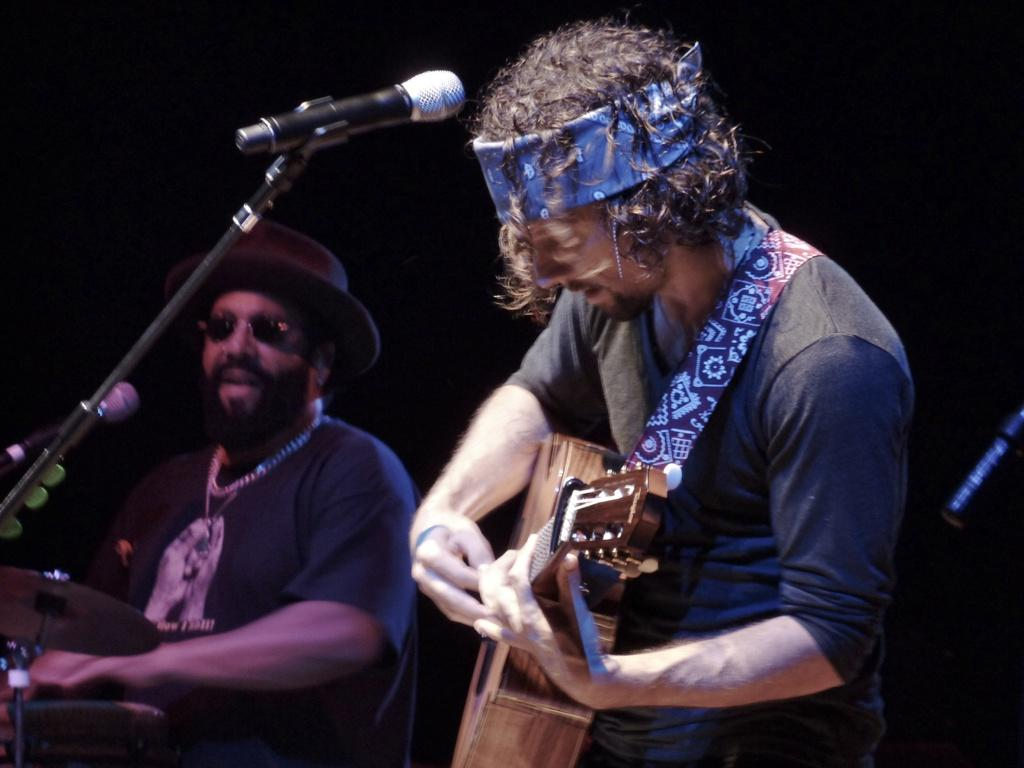What is the man in the image doing? The man is playing a guitar. What is the man in front of? The man is in front of a microphone. Are there any other people in the image? Yes, there is another man in the image. What is the second man doing? The second man is playing a drum. What type of surprise can be seen in the image? There is no surprise present in the image; it features two men playing musical instruments. 